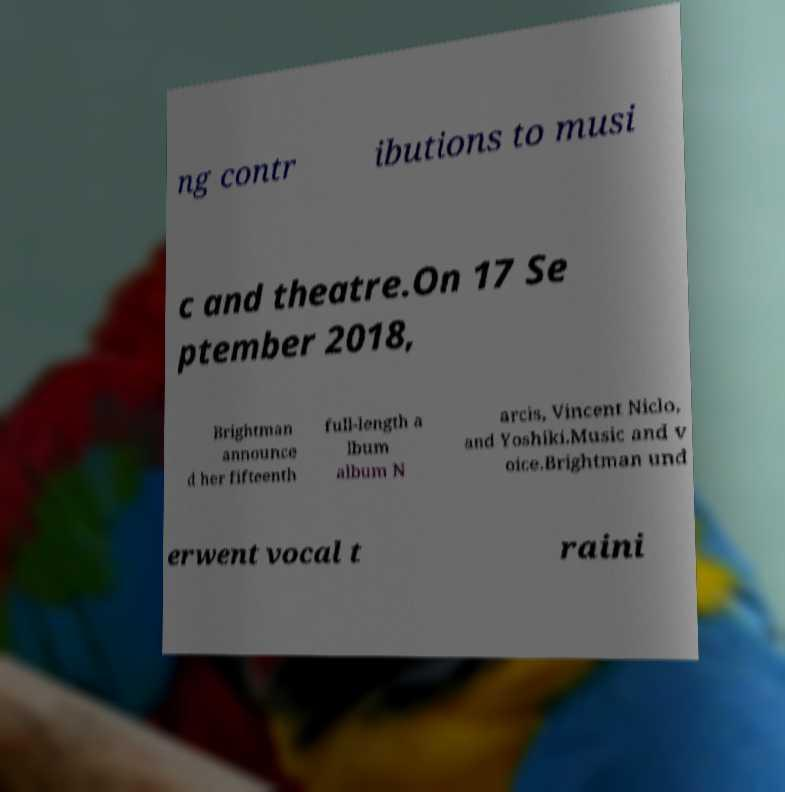Can you read and provide the text displayed in the image?This photo seems to have some interesting text. Can you extract and type it out for me? ng contr ibutions to musi c and theatre.On 17 Se ptember 2018, Brightman announce d her fifteenth full-length a lbum album N arcis, Vincent Niclo, and Yoshiki.Music and v oice.Brightman und erwent vocal t raini 